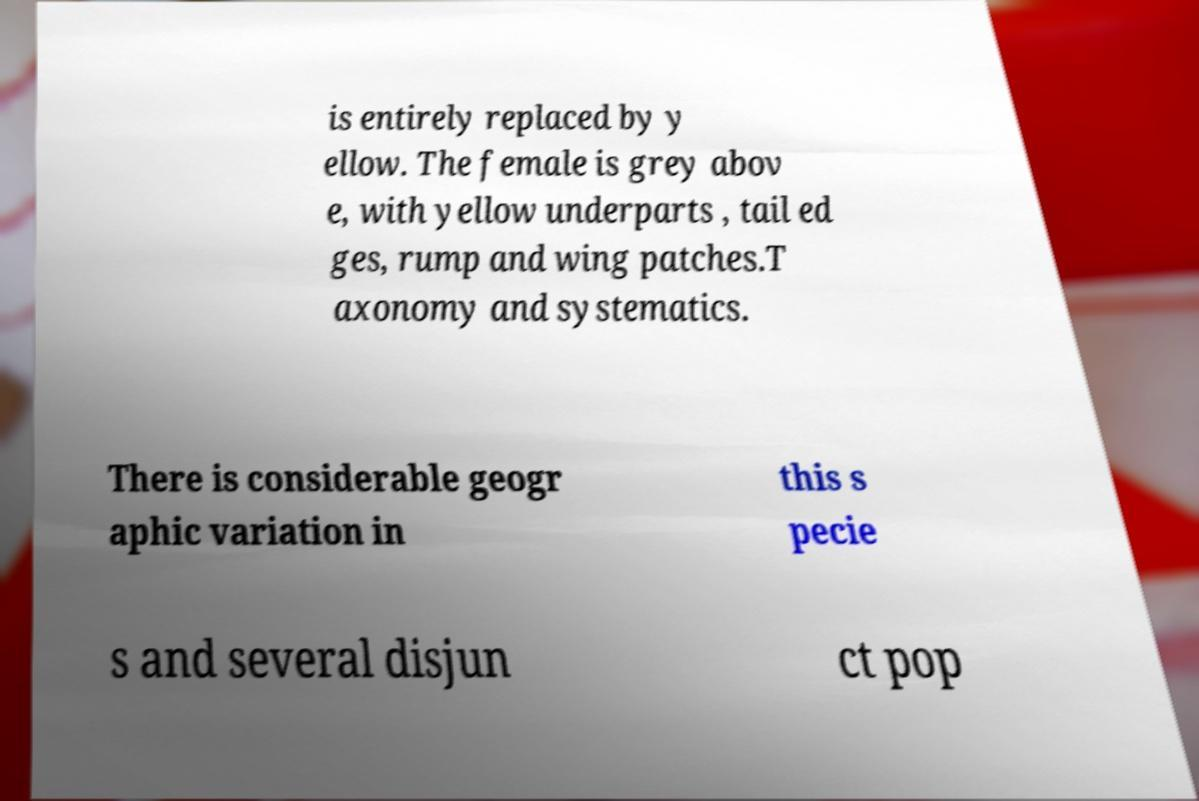Could you assist in decoding the text presented in this image and type it out clearly? is entirely replaced by y ellow. The female is grey abov e, with yellow underparts , tail ed ges, rump and wing patches.T axonomy and systematics. There is considerable geogr aphic variation in this s pecie s and several disjun ct pop 